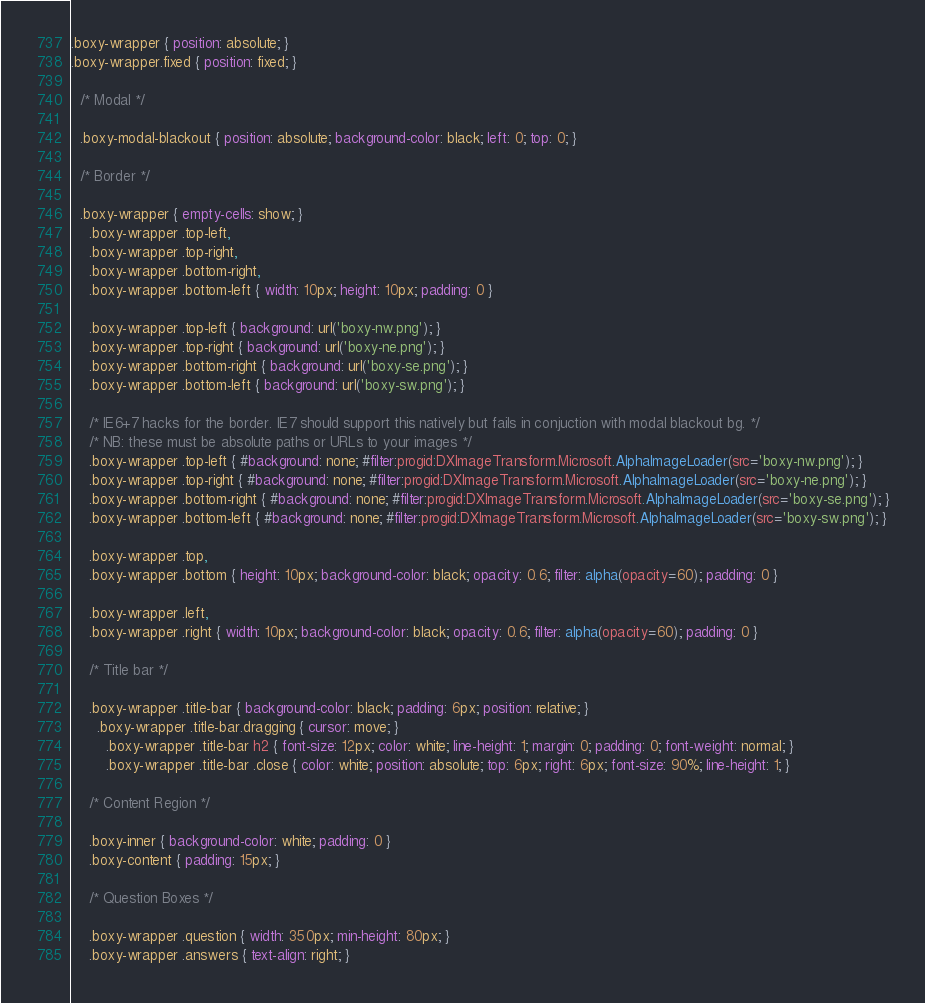Convert code to text. <code><loc_0><loc_0><loc_500><loc_500><_CSS_>.boxy-wrapper { position: absolute; }
.boxy-wrapper.fixed { position: fixed; }

  /* Modal */
  
  .boxy-modal-blackout { position: absolute; background-color: black; left: 0; top: 0; }
  
  /* Border */

  .boxy-wrapper { empty-cells: show; }
	.boxy-wrapper .top-left,
	.boxy-wrapper .top-right,
	.boxy-wrapper .bottom-right,
	.boxy-wrapper .bottom-left { width: 10px; height: 10px; padding: 0 }
	
	.boxy-wrapper .top-left { background: url('boxy-nw.png'); }
	.boxy-wrapper .top-right { background: url('boxy-ne.png'); }
	.boxy-wrapper .bottom-right { background: url('boxy-se.png'); }
	.boxy-wrapper .bottom-left { background: url('boxy-sw.png'); }
	
	/* IE6+7 hacks for the border. IE7 should support this natively but fails in conjuction with modal blackout bg. */
	/* NB: these must be absolute paths or URLs to your images */
	.boxy-wrapper .top-left { #background: none; #filter:progid:DXImageTransform.Microsoft.AlphaImageLoader(src='boxy-nw.png'); }
	.boxy-wrapper .top-right { #background: none; #filter:progid:DXImageTransform.Microsoft.AlphaImageLoader(src='boxy-ne.png'); }
	.boxy-wrapper .bottom-right { #background: none; #filter:progid:DXImageTransform.Microsoft.AlphaImageLoader(src='boxy-se.png'); }
	.boxy-wrapper .bottom-left { #background: none; #filter:progid:DXImageTransform.Microsoft.AlphaImageLoader(src='boxy-sw.png'); }
	
	.boxy-wrapper .top,
	.boxy-wrapper .bottom { height: 10px; background-color: black; opacity: 0.6; filter: alpha(opacity=60); padding: 0 }
	
	.boxy-wrapper .left,
	.boxy-wrapper .right { width: 10px; background-color: black; opacity: 0.6; filter: alpha(opacity=60); padding: 0 }
	
	/* Title bar */
	
	.boxy-wrapper .title-bar { background-color: black; padding: 6px; position: relative; }
	  .boxy-wrapper .title-bar.dragging { cursor: move; }
	    .boxy-wrapper .title-bar h2 { font-size: 12px; color: white; line-height: 1; margin: 0; padding: 0; font-weight: normal; }
	    .boxy-wrapper .title-bar .close { color: white; position: absolute; top: 6px; right: 6px; font-size: 90%; line-height: 1; }
		
	/* Content Region */
	
	.boxy-inner { background-color: white; padding: 0 }
	.boxy-content { padding: 15px; }
	
	/* Question Boxes */

    .boxy-wrapper .question { width: 350px; min-height: 80px; }
    .boxy-wrapper .answers { text-align: right; }
</code> 